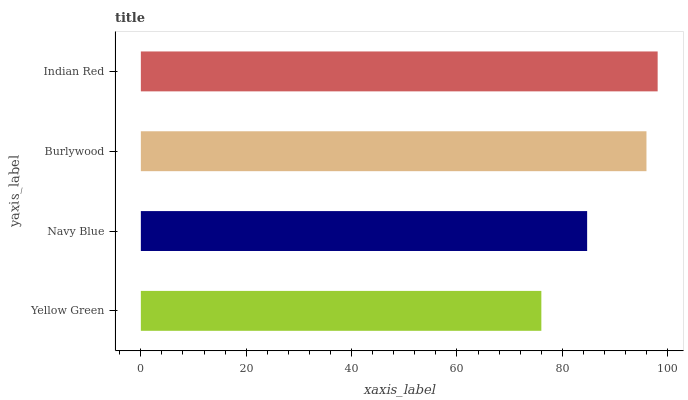Is Yellow Green the minimum?
Answer yes or no. Yes. Is Indian Red the maximum?
Answer yes or no. Yes. Is Navy Blue the minimum?
Answer yes or no. No. Is Navy Blue the maximum?
Answer yes or no. No. Is Navy Blue greater than Yellow Green?
Answer yes or no. Yes. Is Yellow Green less than Navy Blue?
Answer yes or no. Yes. Is Yellow Green greater than Navy Blue?
Answer yes or no. No. Is Navy Blue less than Yellow Green?
Answer yes or no. No. Is Burlywood the high median?
Answer yes or no. Yes. Is Navy Blue the low median?
Answer yes or no. Yes. Is Navy Blue the high median?
Answer yes or no. No. Is Burlywood the low median?
Answer yes or no. No. 